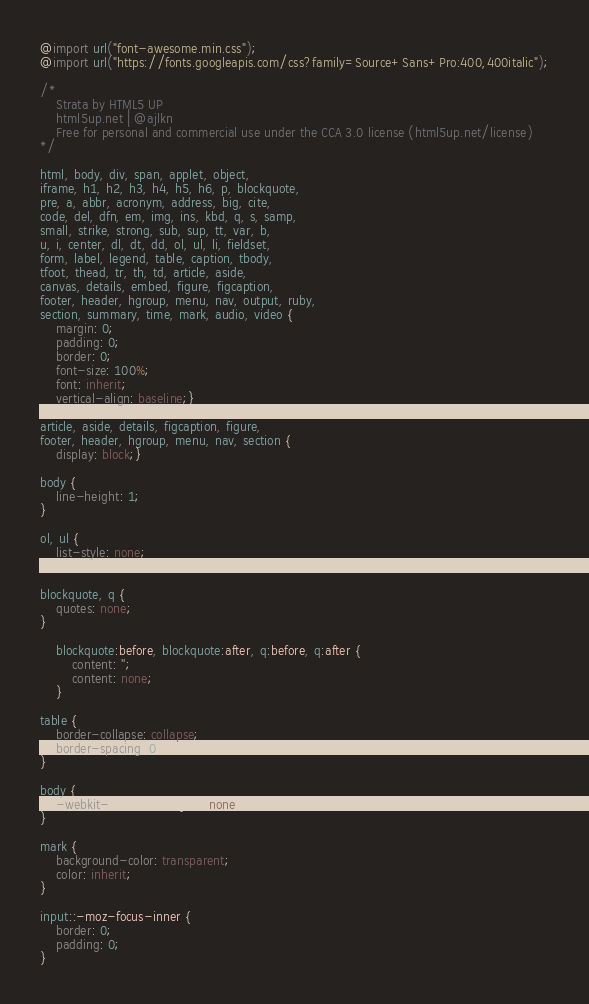Convert code to text. <code><loc_0><loc_0><loc_500><loc_500><_CSS_>@import url("font-awesome.min.css");
@import url("https://fonts.googleapis.com/css?family=Source+Sans+Pro:400,400italic");

/*
	Strata by HTML5 UP
	html5up.net | @ajlkn
	Free for personal and commercial use under the CCA 3.0 license (html5up.net/license)
*/

html, body, div, span, applet, object,
iframe, h1, h2, h3, h4, h5, h6, p, blockquote,
pre, a, abbr, acronym, address, big, cite,
code, del, dfn, em, img, ins, kbd, q, s, samp,
small, strike, strong, sub, sup, tt, var, b,
u, i, center, dl, dt, dd, ol, ul, li, fieldset,
form, label, legend, table, caption, tbody,
tfoot, thead, tr, th, td, article, aside,
canvas, details, embed, figure, figcaption,
footer, header, hgroup, menu, nav, output, ruby,
section, summary, time, mark, audio, video {
	margin: 0;
	padding: 0;
	border: 0;
	font-size: 100%;
	font: inherit;
	vertical-align: baseline;}

article, aside, details, figcaption, figure,
footer, header, hgroup, menu, nav, section {
	display: block;}

body {
	line-height: 1;
}

ol, ul {
	list-style: none;
}

blockquote, q {
	quotes: none;
}

	blockquote:before, blockquote:after, q:before, q:after {
		content: '';
		content: none;
	}

table {
	border-collapse: collapse;
	border-spacing: 0;
}

body {
	-webkit-text-size-adjust: none;
}

mark {
	background-color: transparent;
	color: inherit;
}

input::-moz-focus-inner {
	border: 0;
	padding: 0;
}
</code> 